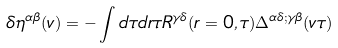Convert formula to latex. <formula><loc_0><loc_0><loc_500><loc_500>\delta \eta ^ { \alpha \beta } ( v ) = - \int d \tau d r \tau R ^ { \gamma \delta } ( r = 0 , \tau ) \Delta ^ { \alpha \delta ; \gamma \beta } ( v \tau )</formula> 